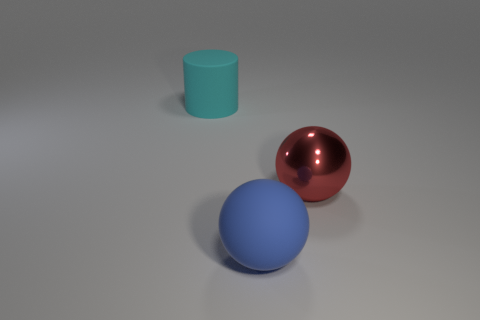How many other things are made of the same material as the big cylinder?
Keep it short and to the point. 1. The large thing that is made of the same material as the large blue ball is what shape?
Keep it short and to the point. Cylinder. Is there anything else that has the same color as the large rubber sphere?
Ensure brevity in your answer.  No. Is the number of balls in front of the red thing greater than the number of yellow matte balls?
Your answer should be very brief. Yes. There is a big blue matte object; is it the same shape as the matte thing on the left side of the blue thing?
Ensure brevity in your answer.  No. What number of metallic spheres are the same size as the blue rubber sphere?
Your answer should be compact. 1. How many big things are in front of the matte thing that is in front of the big object that is left of the big rubber ball?
Give a very brief answer. 0. Are there an equal number of matte cylinders that are to the right of the large blue object and big red things that are to the left of the large red ball?
Provide a short and direct response. Yes. How many other large cyan matte objects are the same shape as the big cyan thing?
Your answer should be very brief. 0. Are there any big blue cylinders made of the same material as the red sphere?
Provide a succinct answer. No. 